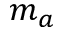Convert formula to latex. <formula><loc_0><loc_0><loc_500><loc_500>m _ { a }</formula> 